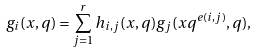<formula> <loc_0><loc_0><loc_500><loc_500>g _ { i } ( x , q ) = \sum _ { j = 1 } ^ { r } h _ { i , j } ( x , q ) g _ { j } ( x q ^ { e ( i , j ) } , q ) ,</formula> 